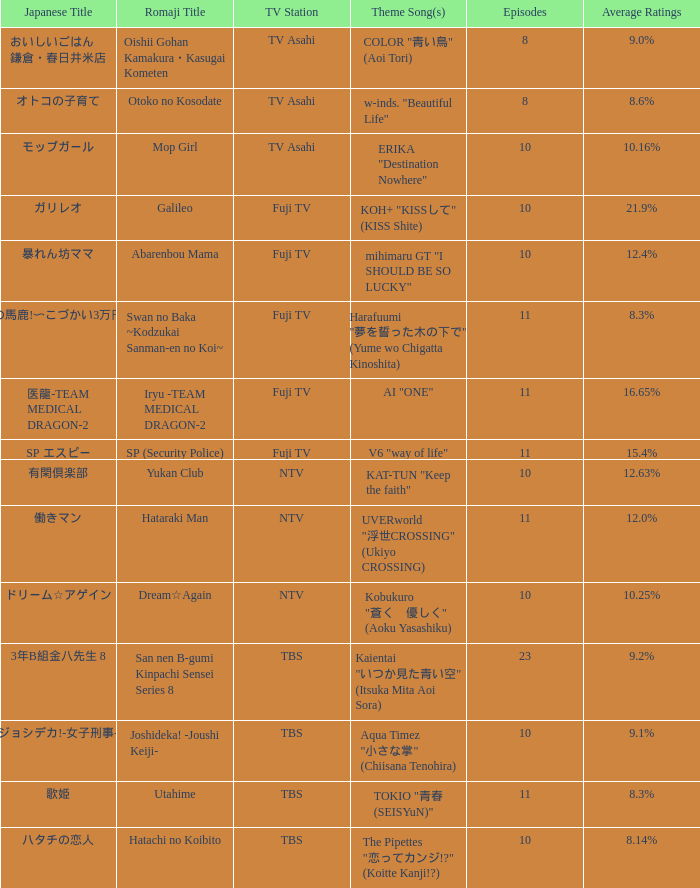Which song is used as the theme for the yukan club? KAT-TUN "Keep the faith". Would you be able to parse every entry in this table? {'header': ['Japanese Title', 'Romaji Title', 'TV Station', 'Theme Song(s)', 'Episodes', 'Average Ratings'], 'rows': [['おいしいごはん 鎌倉・春日井米店', 'Oishii Gohan Kamakura・Kasugai Kometen', 'TV Asahi', 'COLOR "青い鳥" (Aoi Tori)', '8', '9.0%'], ['オトコの子育て', 'Otoko no Kosodate', 'TV Asahi', 'w-inds. "Beautiful Life"', '8', '8.6%'], ['モップガール', 'Mop Girl', 'TV Asahi', 'ERIKA "Destination Nowhere"', '10', '10.16%'], ['ガリレオ', 'Galileo', 'Fuji TV', 'KOH+ "KISSして" (KISS Shite)', '10', '21.9%'], ['暴れん坊ママ', 'Abarenbou Mama', 'Fuji TV', 'mihimaru GT "I SHOULD BE SO LUCKY"', '10', '12.4%'], ['スワンの馬鹿!〜こづかい3万円の恋〜', 'Swan no Baka ~Kodzukai Sanman-en no Koi~', 'Fuji TV', 'Harafuumi "夢を誓った木の下で" (Yume wo Chigatta Kinoshita)', '11', '8.3%'], ['医龍-TEAM MEDICAL DRAGON-2', 'Iryu -TEAM MEDICAL DRAGON-2', 'Fuji TV', 'AI "ONE"', '11', '16.65%'], ['SP エスピー', 'SP (Security Police)', 'Fuji TV', 'V6 "way of life"', '11', '15.4%'], ['有閑倶楽部', 'Yukan Club', 'NTV', 'KAT-TUN "Keep the faith"', '10', '12.63%'], ['働きマン', 'Hataraki Man', 'NTV', 'UVERworld "浮世CROSSING" (Ukiyo CROSSING)', '11', '12.0%'], ['ドリーム☆アゲイン', 'Dream☆Again', 'NTV', 'Kobukuro "蒼く\u3000優しく" (Aoku Yasashiku)', '10', '10.25%'], ['3年B組金八先生 8', 'San nen B-gumi Kinpachi Sensei Series 8', 'TBS', 'Kaientai "いつか見た青い空" (Itsuka Mita Aoi Sora)', '23', '9.2%'], ['ジョシデカ!-女子刑事-', 'Joshideka! -Joushi Keiji-', 'TBS', 'Aqua Timez "小さな掌" (Chiisana Tenohira)', '10', '9.1%'], ['歌姫', 'Utahime', 'TBS', 'TOKIO "青春 (SEISYuN)"', '11', '8.3%'], ['ハタチの恋人', 'Hatachi no Koibito', 'TBS', 'The Pipettes "恋ってカンジ!?" (Koitte Kanji!?)', '10', '8.14%']]} 